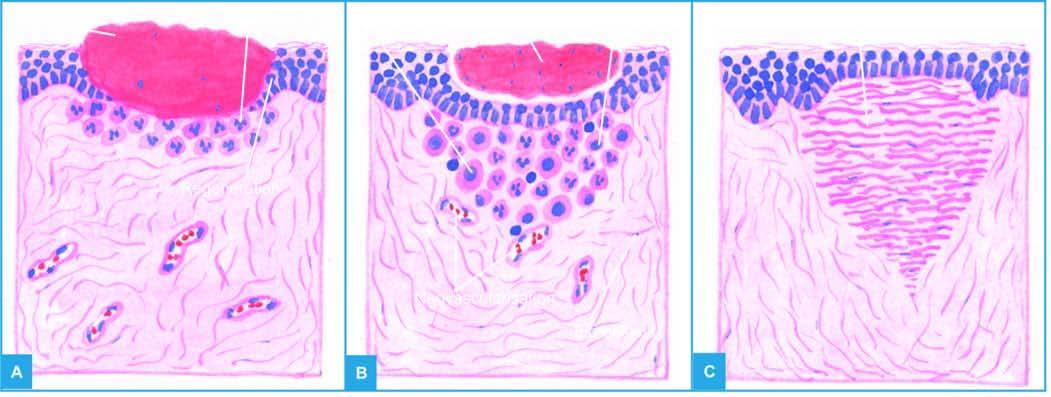s a scar smaller than the original wound in figure c left after contraction of the wound?
Answer the question using a single word or phrase. No 